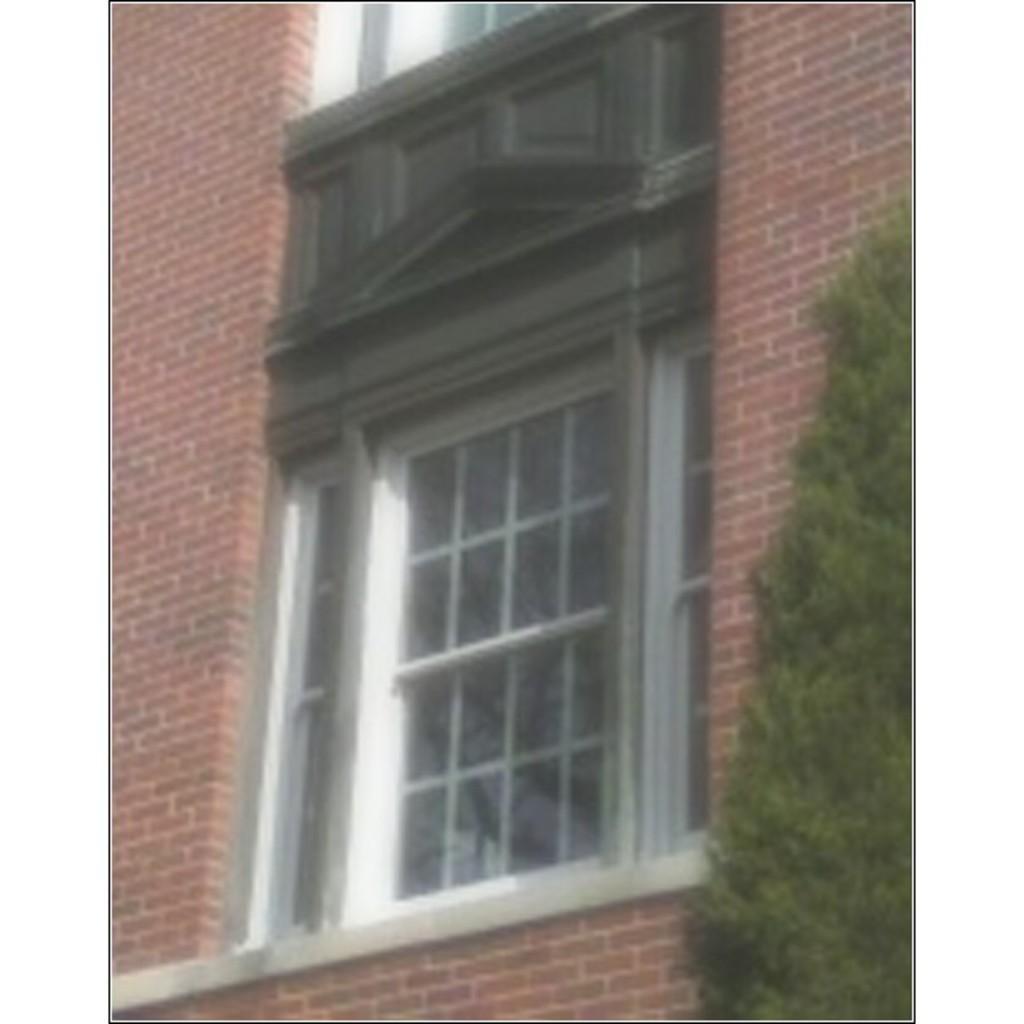Can you describe this image briefly? In this image we can see brick wall and glass window. Right side of the image tree is there. 